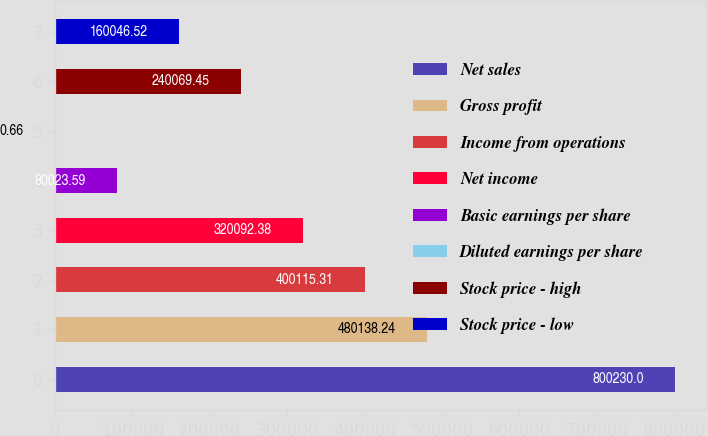<chart> <loc_0><loc_0><loc_500><loc_500><bar_chart><fcel>Net sales<fcel>Gross profit<fcel>Income from operations<fcel>Net income<fcel>Basic earnings per share<fcel>Diluted earnings per share<fcel>Stock price - high<fcel>Stock price - low<nl><fcel>800230<fcel>480138<fcel>400115<fcel>320092<fcel>80023.6<fcel>0.66<fcel>240069<fcel>160047<nl></chart> 